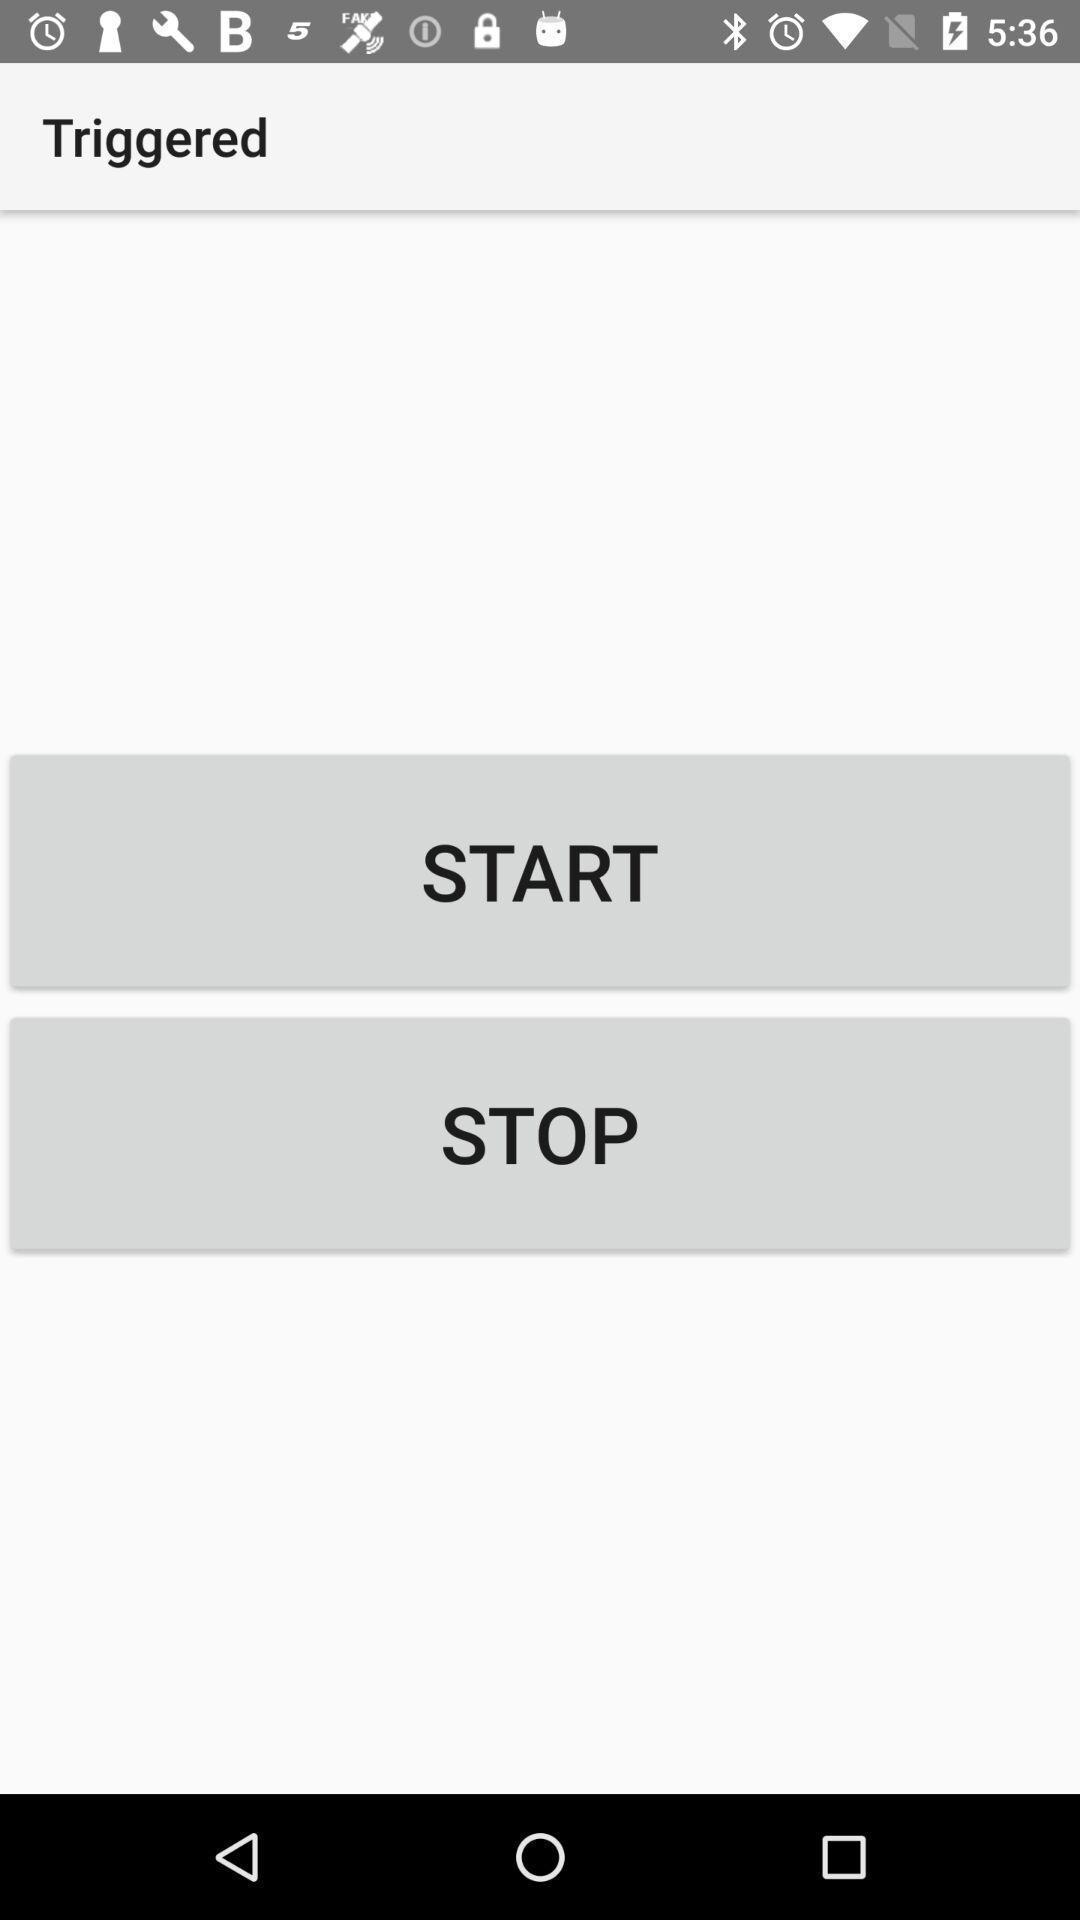Describe the key features of this screenshot. Start page. 